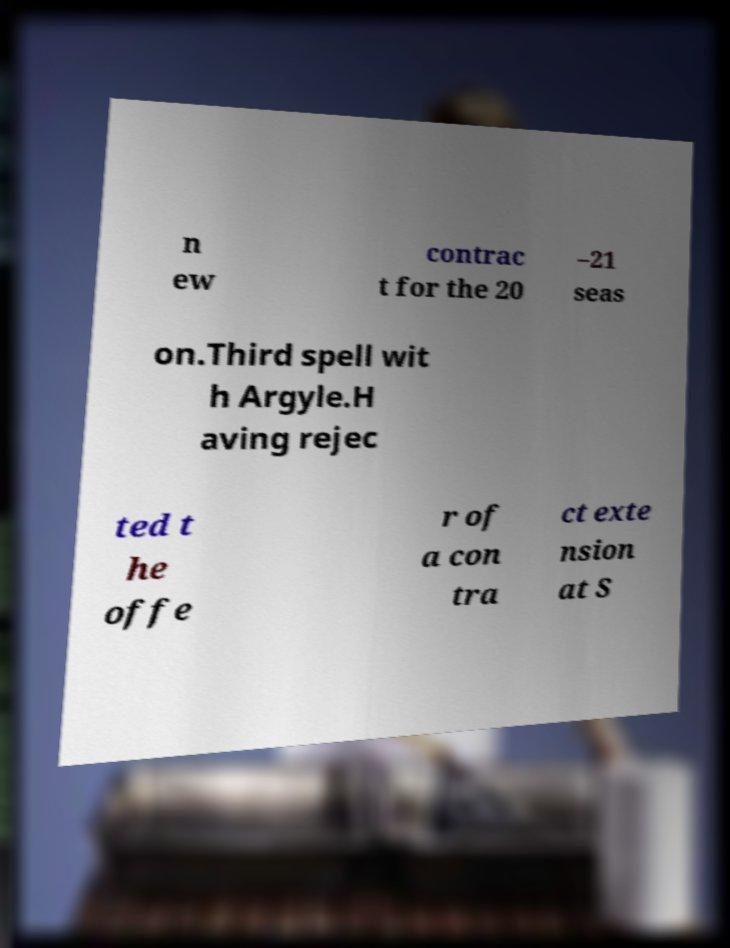Please identify and transcribe the text found in this image. n ew contrac t for the 20 –21 seas on.Third spell wit h Argyle.H aving rejec ted t he offe r of a con tra ct exte nsion at S 